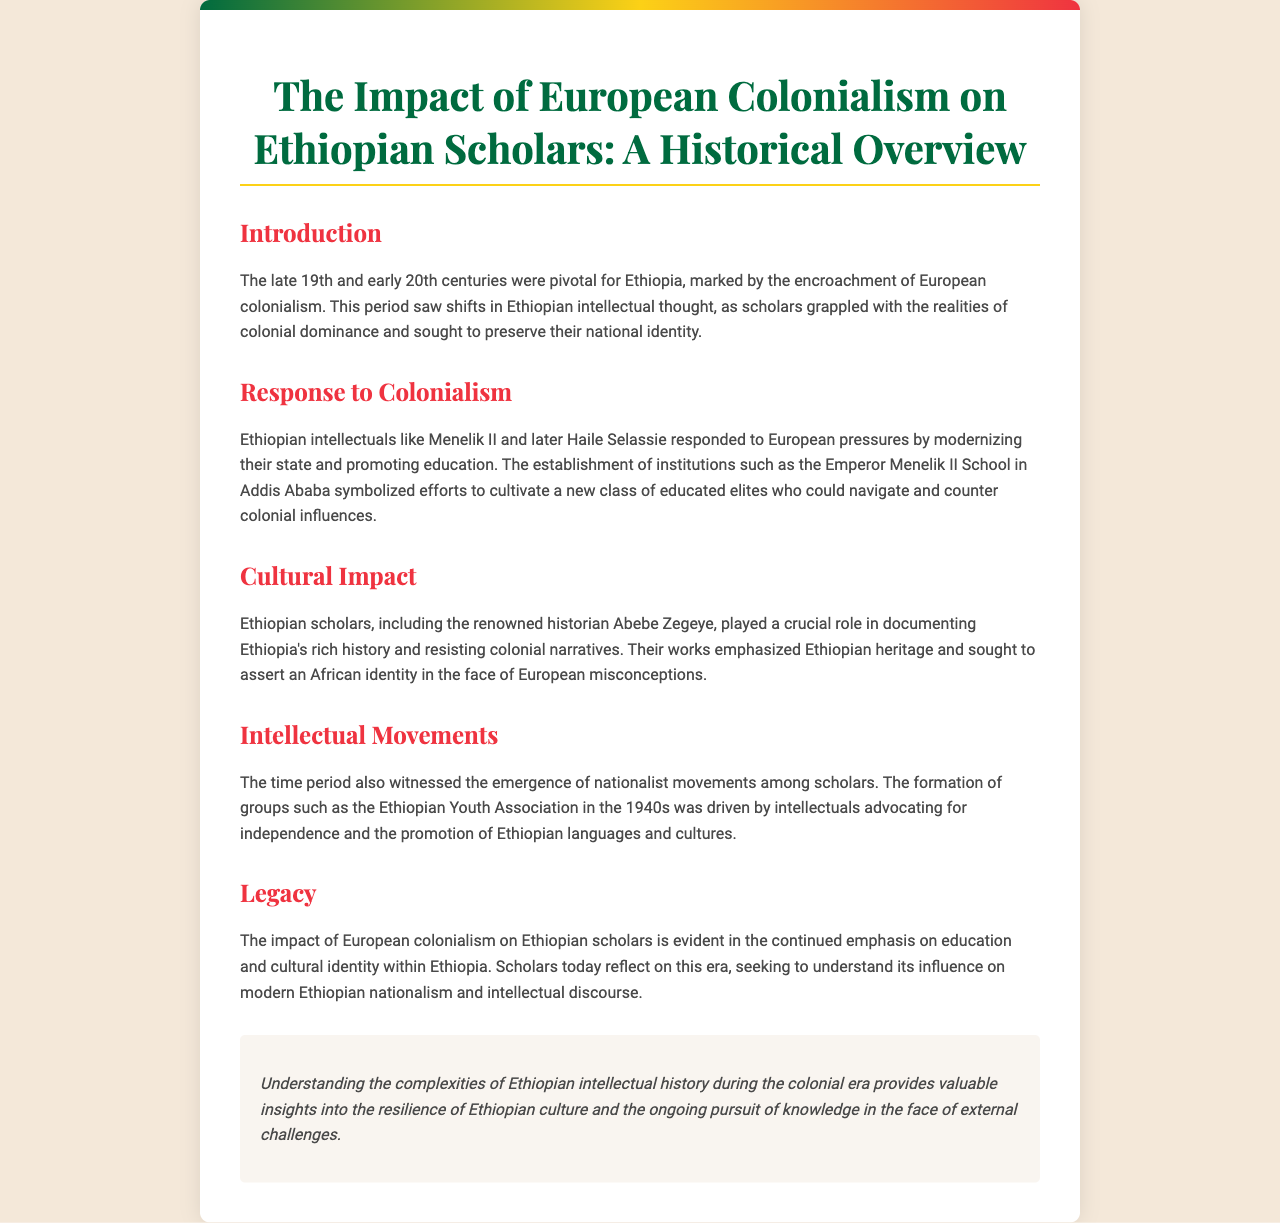What is the title of the brochure? The title of the brochure is prominently displayed at the top and summarizes the main theme of the document.
Answer: The Impact of European Colonialism on Ethiopian Scholars: A Historical Overview Who responded to European pressures by modernizing the state? The document mentions Ethiopian leaders who took steps to counter colonialism and promote education, specifically referencing their roles in this context.
Answer: Menelik II What institution was established to cultivate a new class of educated elites? An educational institution is highlighted as a key response to colonialism, reflecting the efforts promoted by Ethiopian leaders.
Answer: Emperor Menelik II School In which decade did the Ethiopian Youth Association form? The document specifies the time period during which nationalist movements emerged, providing clear information about the organization’s timeline.
Answer: 1940s Who is the renowned historian mentioned in the brochure? The brochure notes a specific scholar who was influential in documenting Ethiopian history, indicating his significance in resisting colonial narratives.
Answer: Abebe Zegeye What are scholars today seeking to understand regarding the colonial era? The document indicates a reflective approach taken by contemporary scholars about the past influences on Ethiopian identity and nationalism.
Answer: Its influence on modern Ethiopian nationalism What does the conclusion emphasize about Ethiopian culture? The conclusion remarks on a particular aspect of Ethiopian culture, focusing on resilience and knowledge in challenging times.
Answer: Resilience What is the background color used in the brochure? The design choice of colors including the overall aesthetic and mood of the document is noted at the beginning.
Answer: #f4e8d9 